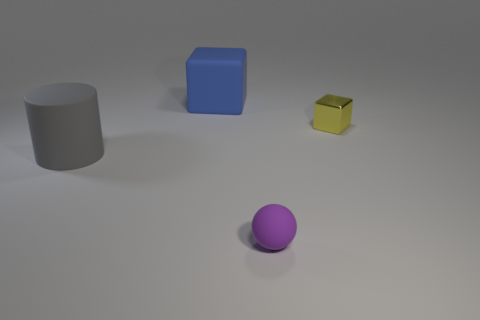How many metal things are either blue blocks or tiny yellow spheres?
Your response must be concise. 0. Do the big matte object to the left of the blue cube and the small object that is to the right of the small matte ball have the same shape?
Your answer should be compact. No. How many small things are in front of the tiny metallic object?
Your response must be concise. 1. Are there any blue cubes that have the same material as the blue thing?
Give a very brief answer. No. There is a cube that is the same size as the gray object; what is its material?
Provide a short and direct response. Rubber. Is the material of the tiny purple sphere the same as the tiny cube?
Provide a short and direct response. No. How many things are either big matte cylinders or small blue metal cubes?
Give a very brief answer. 1. What shape is the rubber thing that is behind the gray object?
Your answer should be compact. Cube. What is the color of the small object that is the same material as the large blue block?
Give a very brief answer. Purple. There is another big object that is the same shape as the metallic thing; what material is it?
Keep it short and to the point. Rubber. 